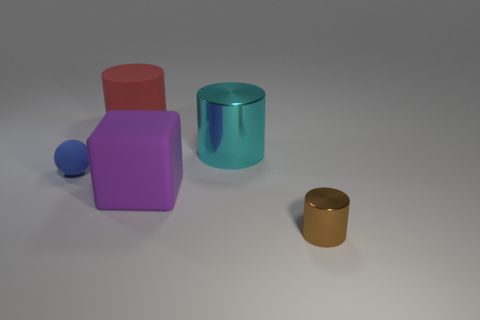What number of things are either cyan cylinders or spheres? There are two items that fit the criteria in the image: one cyan cylinder and one blue sphere. 